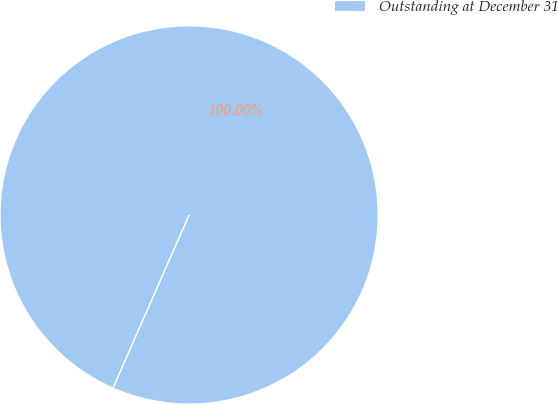<chart> <loc_0><loc_0><loc_500><loc_500><pie_chart><fcel>Outstanding at December 31<nl><fcel>100.0%<nl></chart> 